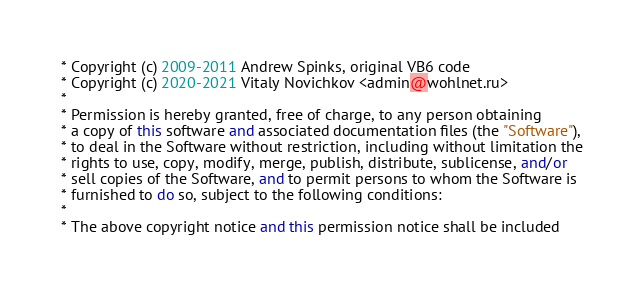Convert code to text. <code><loc_0><loc_0><loc_500><loc_500><_C++_> * Copyright (c) 2009-2011 Andrew Spinks, original VB6 code
 * Copyright (c) 2020-2021 Vitaly Novichkov <admin@wohlnet.ru>
 *
 * Permission is hereby granted, free of charge, to any person obtaining
 * a copy of this software and associated documentation files (the "Software"),
 * to deal in the Software without restriction, including without limitation the
 * rights to use, copy, modify, merge, publish, distribute, sublicense, and/or
 * sell copies of the Software, and to permit persons to whom the Software is
 * furnished to do so, subject to the following conditions:
 *
 * The above copyright notice and this permission notice shall be included</code> 